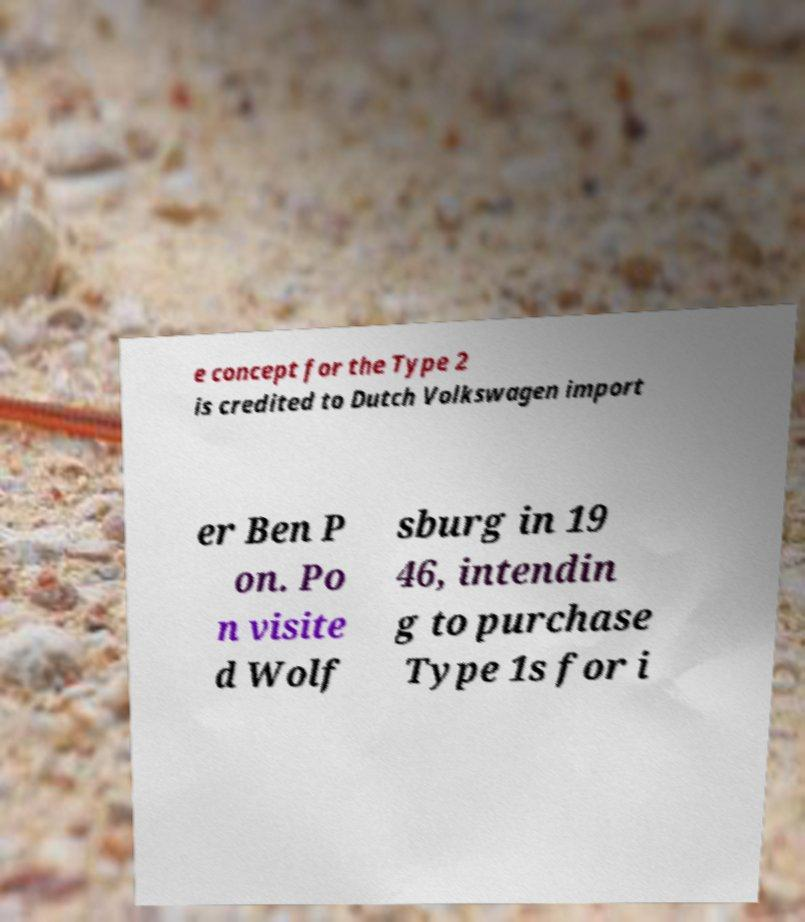Could you extract and type out the text from this image? e concept for the Type 2 is credited to Dutch Volkswagen import er Ben P on. Po n visite d Wolf sburg in 19 46, intendin g to purchase Type 1s for i 